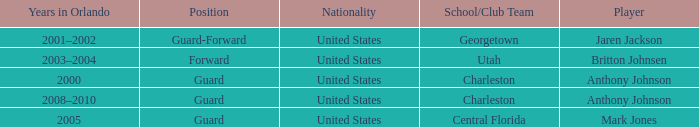Who was the Player that had the Position, guard-forward? Jaren Jackson. 